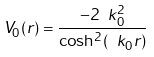<formula> <loc_0><loc_0><loc_500><loc_500>V _ { 0 } ( r ) = \frac { - 2 \ k _ { 0 } ^ { 2 } } { \cosh ^ { 2 } ( \ k _ { 0 } r ) }</formula> 